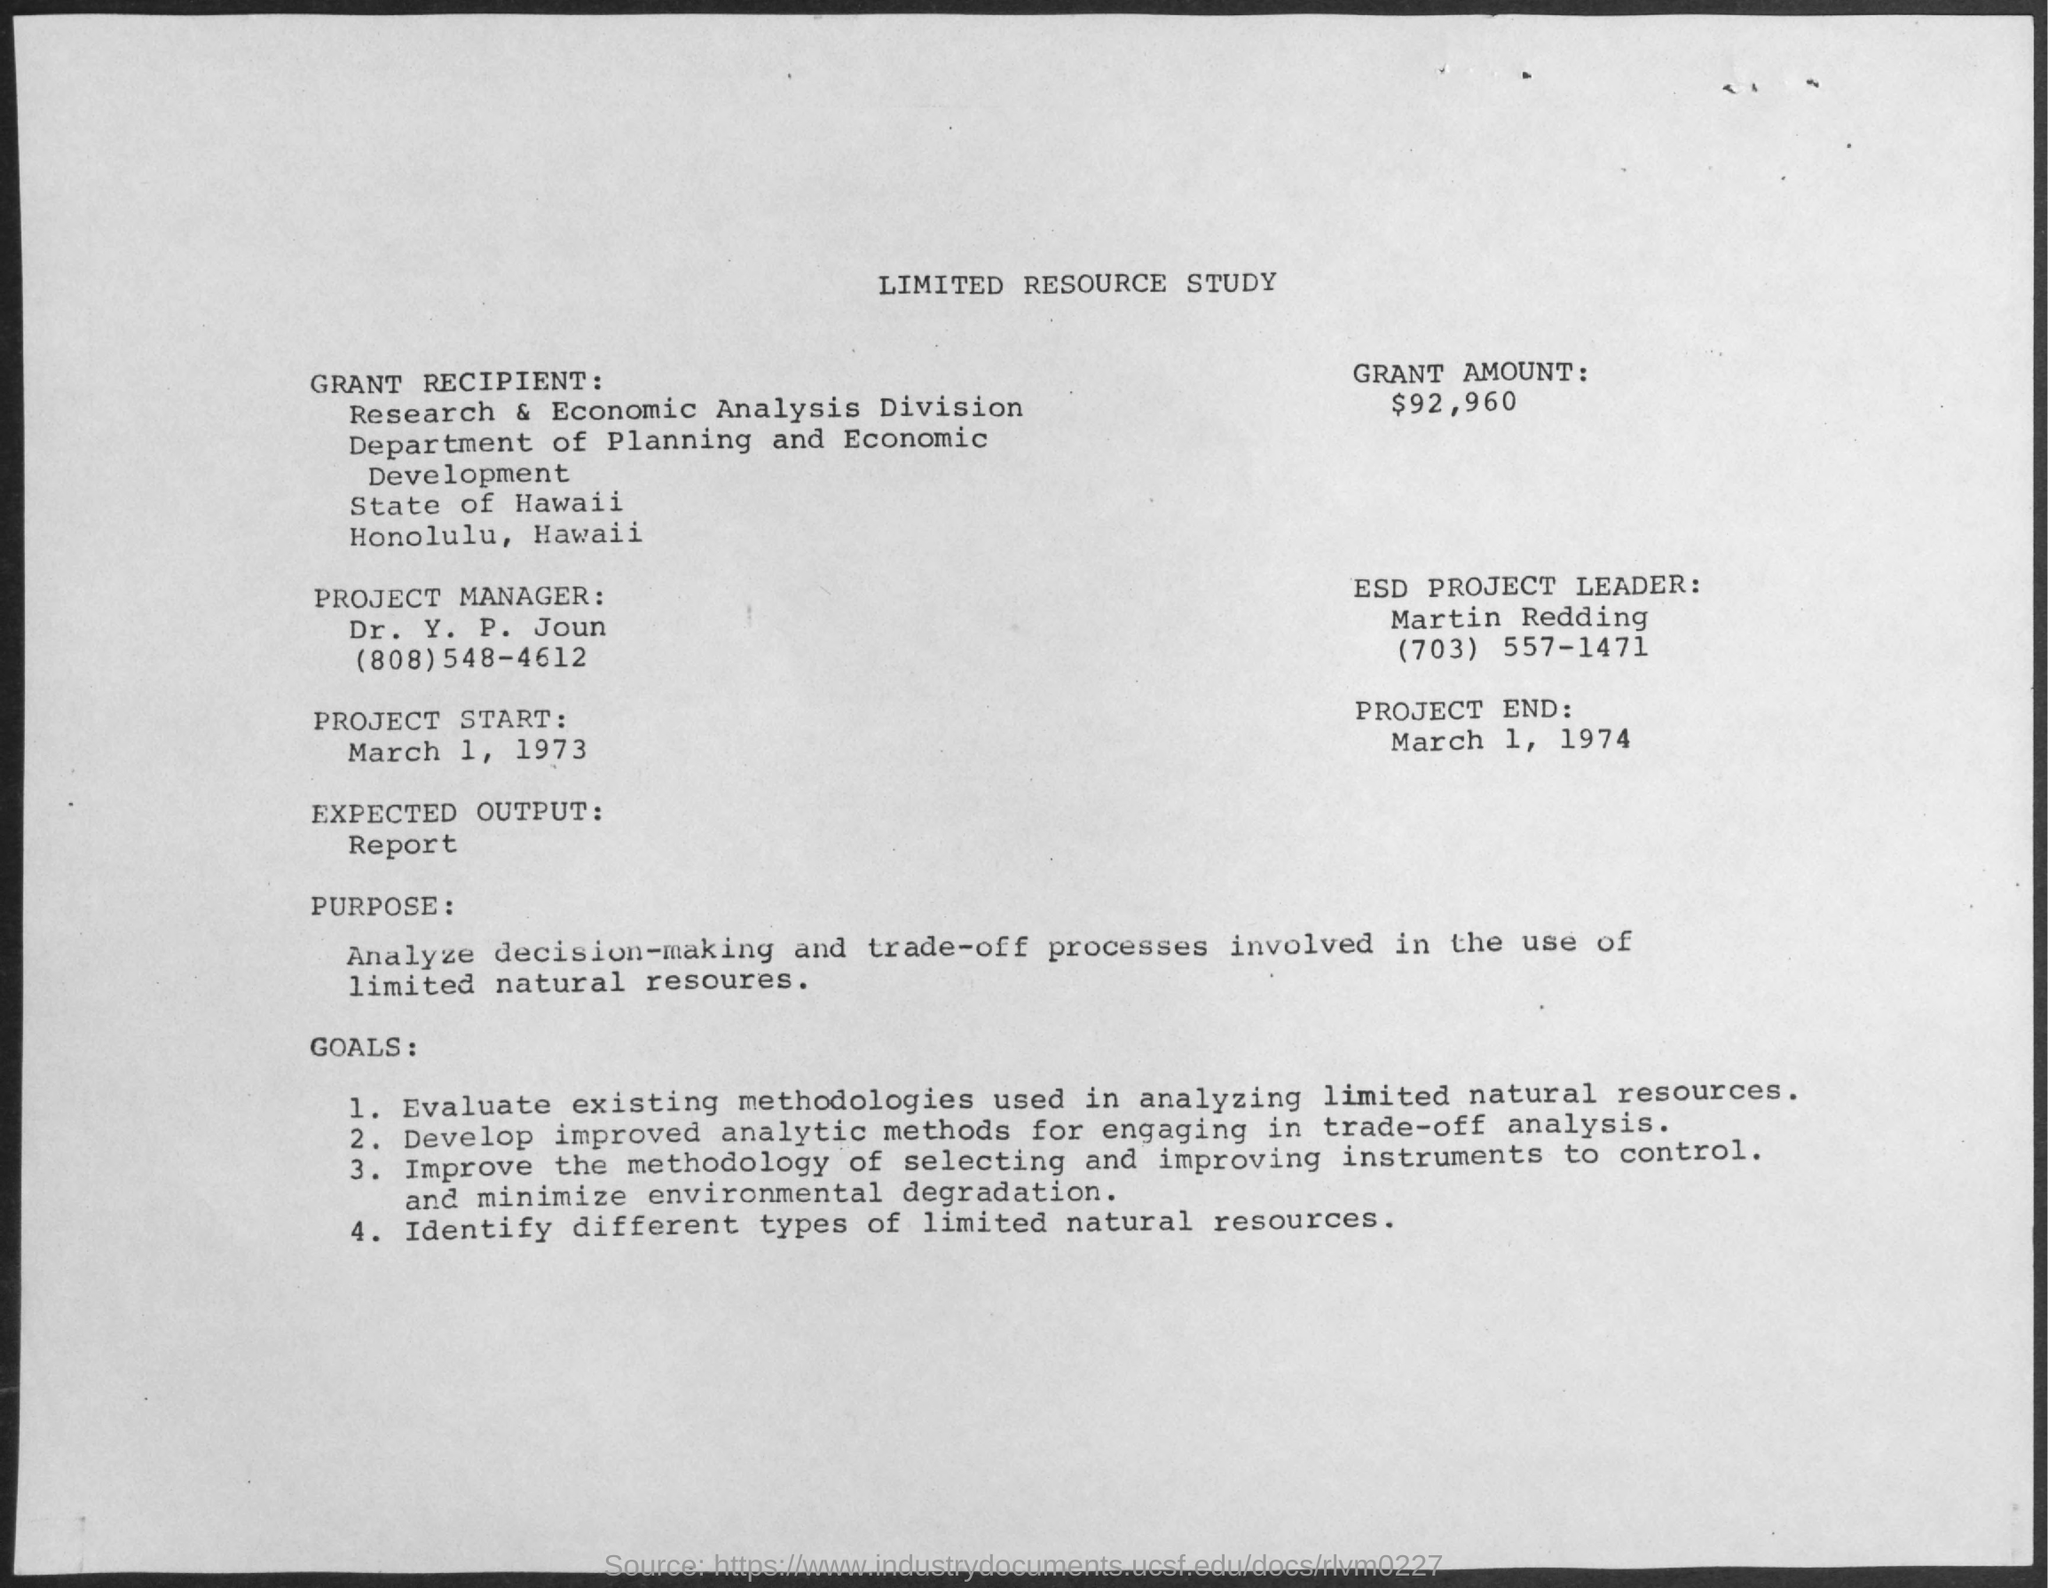Indicate a few pertinent items in this graphic. The Department of Planning and Economic Development is the name of the department mentioned in the given resource study. The recipient of the grant is the Research & Economic Analysis Division. The start date of the project is March 1, 1973. The date of the project's end is March 1, 1974. The leader of the ESD project is named Martin Redding. 